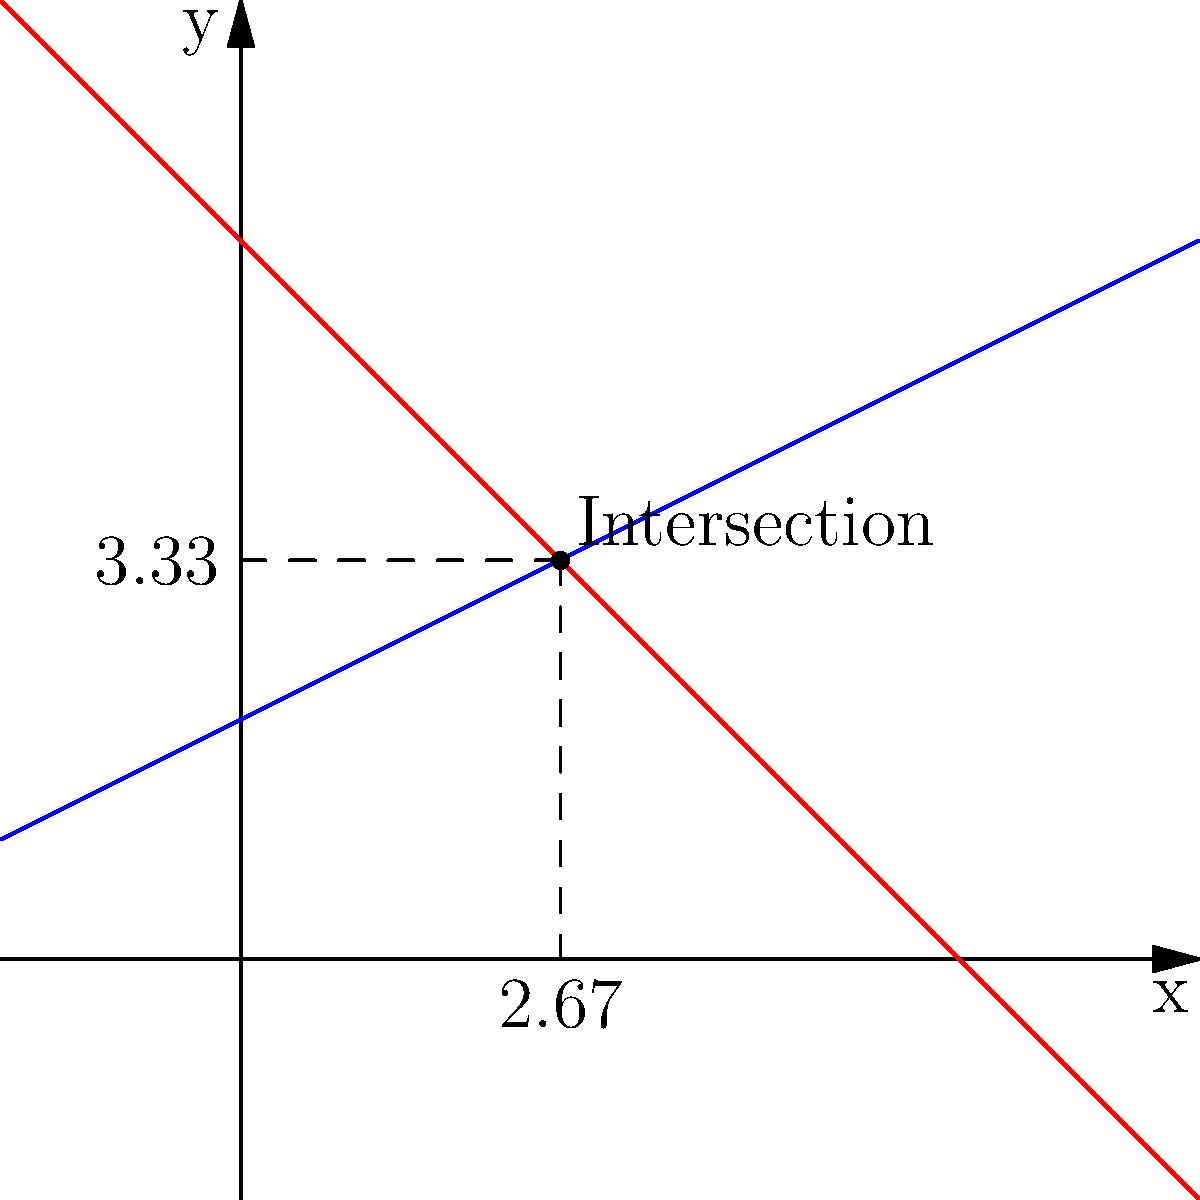Two ships are following different routes plotted on a coordinate plane. Route A is represented by the equation $y = 0.5x + 2$, while Route B is given by $y = -x + 6$. At what point do these routes intersect? Give the coordinates of the intersection point to two decimal places. To find the intersection point of the two routes, we need to solve the system of equations:

1) $y = 0.5x + 2$ (Route A)
2) $y = -x + 6$ (Route B)

At the intersection point, the y-coordinates will be equal. So we can set the right sides of the equations equal to each other:

3) $0.5x + 2 = -x + 6$

Now, let's solve for x:

4) $0.5x + x = 6 - 2$
5) $1.5x = 4$
6) $x = 4 / 1.5 = 2.67$ (rounded to two decimal places)

To find y, we can substitute this x-value into either of the original equations. Let's use Route A:

7) $y = 0.5(2.67) + 2$
8) $y = 1.33 + 2 = 3.33$

Therefore, the intersection point is (2.67, 3.33).
Answer: (2.67, 3.33) 